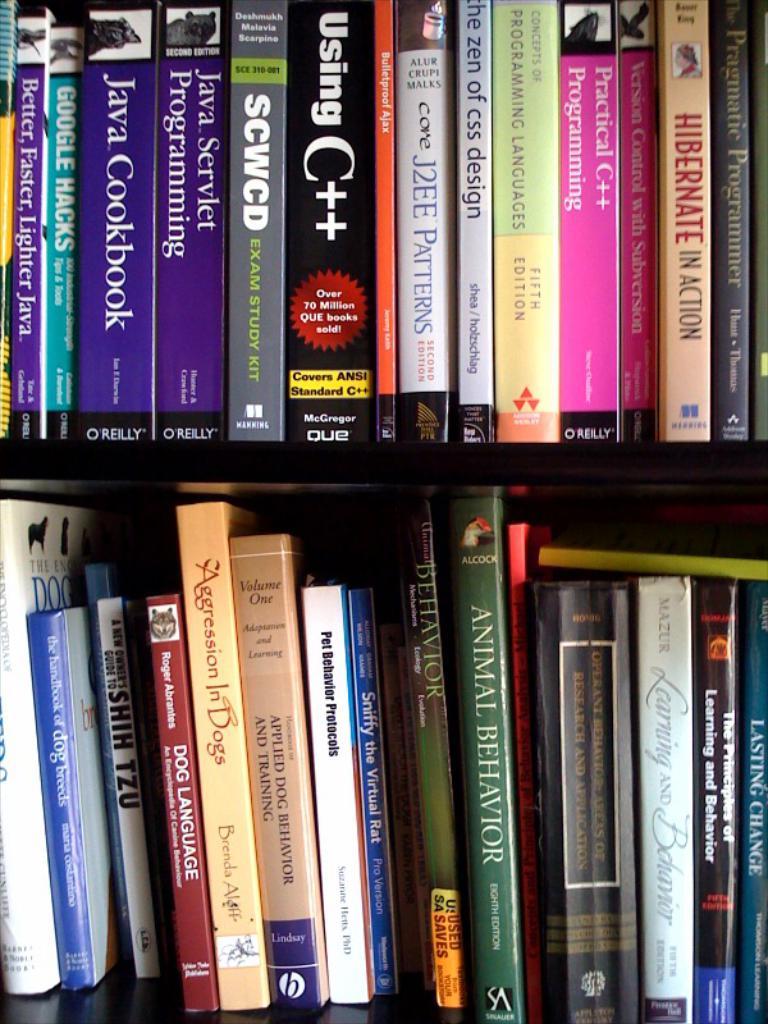What is the title of the red book on the bottom shelf?
Your response must be concise. Dog language. 